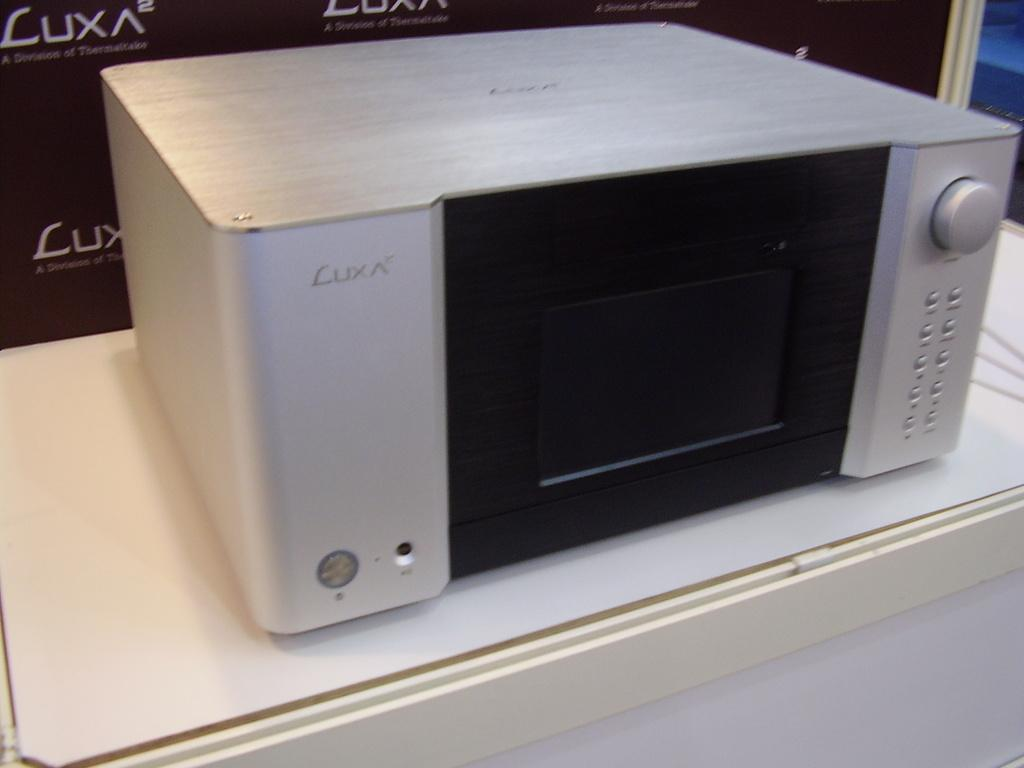<image>
Render a clear and concise summary of the photo. A silver and black device from Luxa rests on a counter. 